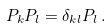Convert formula to latex. <formula><loc_0><loc_0><loc_500><loc_500>P _ { k } P _ { l } = \delta _ { k l } P _ { l } \, .</formula> 